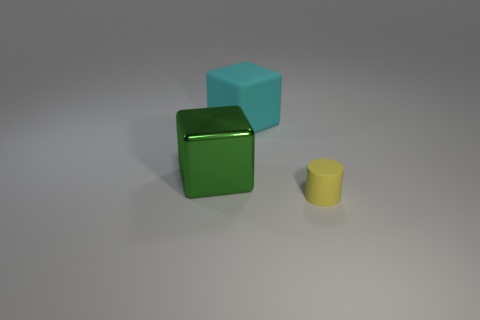Add 2 green shiny things. How many objects exist? 5 Subtract all cylinders. How many objects are left? 2 Add 2 yellow cylinders. How many yellow cylinders are left? 3 Add 3 big cyan things. How many big cyan things exist? 4 Subtract 0 purple cylinders. How many objects are left? 3 Subtract all green things. Subtract all small yellow rubber objects. How many objects are left? 1 